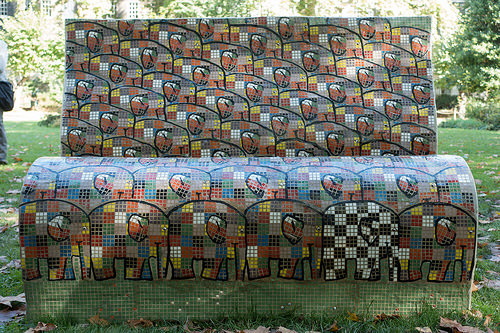<image>
Is there a grass behind the bank? Yes. From this viewpoint, the grass is positioned behind the bank, with the bank partially or fully occluding the grass. 